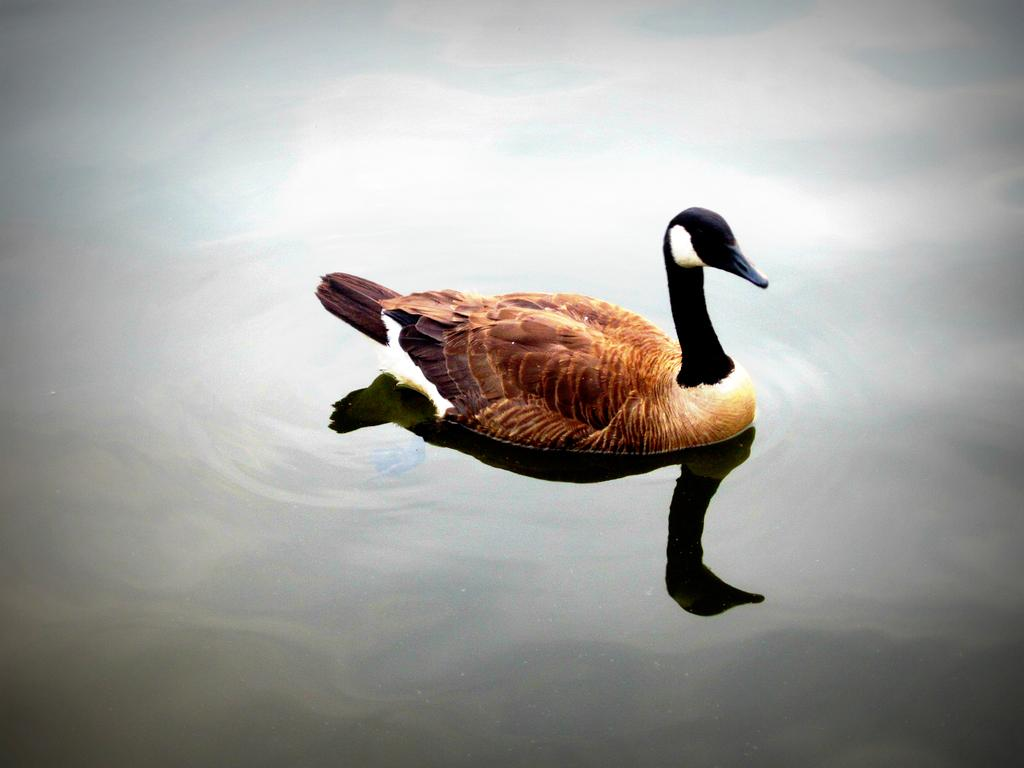What type of animal is in the image? There is a bird in the image. Where is the bird located? The bird is on the water. What colors can be seen on the bird? The bird has brown, black, and white coloring. What type of toy is the bird playing with in the image? There is no toy present in the image, and the bird is not shown playing with anything. 